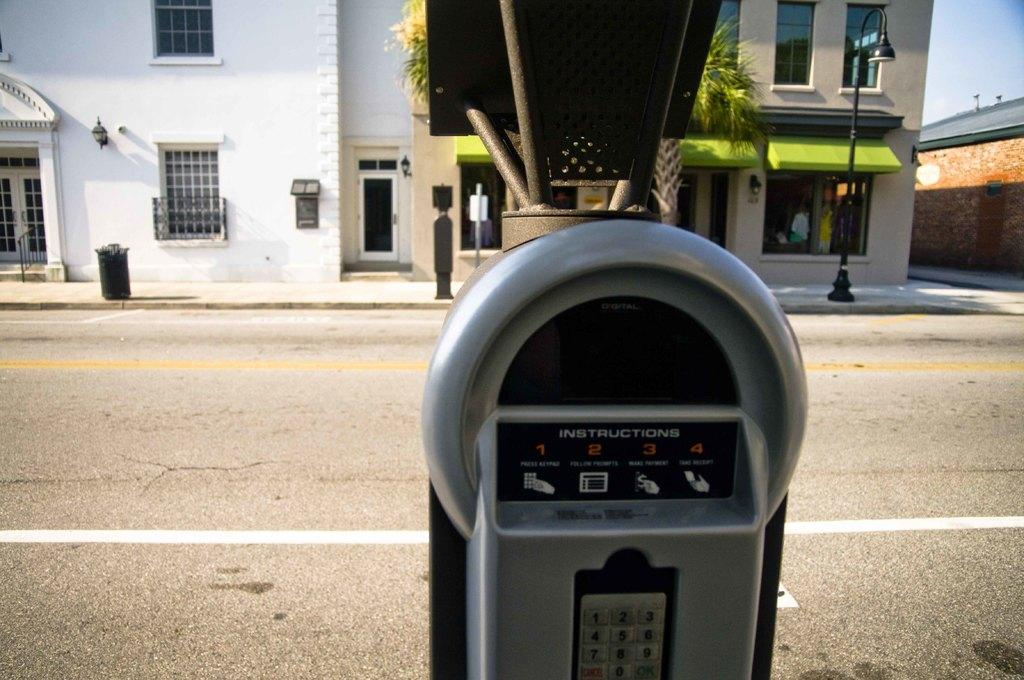<image>
Give a short and clear explanation of the subsequent image. A parking meter's instructions are numbered one through four. 